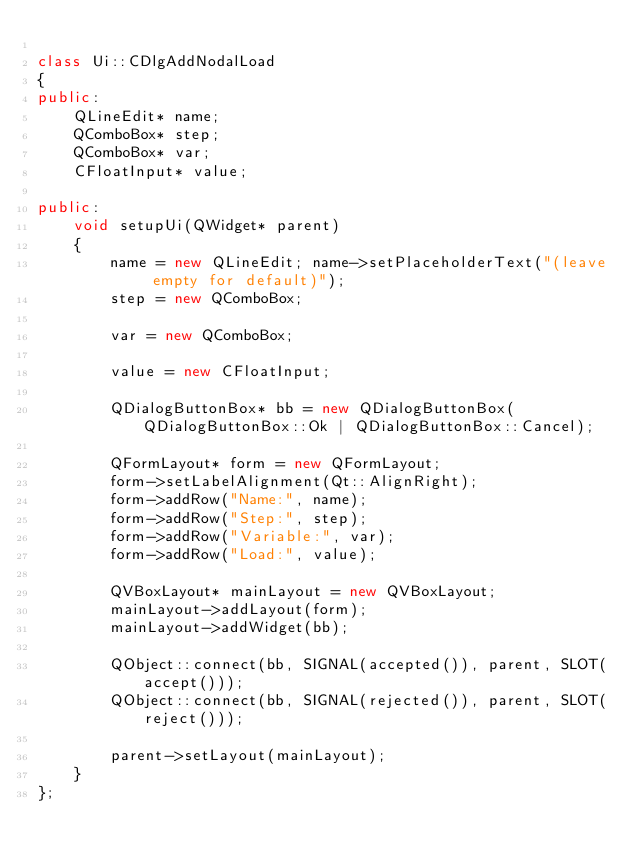<code> <loc_0><loc_0><loc_500><loc_500><_C++_>
class Ui::CDlgAddNodalLoad
{
public:
	QLineEdit* name;
	QComboBox* step;
	QComboBox* var;
	CFloatInput* value;

public:
	void setupUi(QWidget* parent)
	{
		name = new QLineEdit; name->setPlaceholderText("(leave empty for default)");
		step = new QComboBox;

		var = new QComboBox;

		value = new CFloatInput;

		QDialogButtonBox* bb = new QDialogButtonBox(QDialogButtonBox::Ok | QDialogButtonBox::Cancel);

		QFormLayout* form = new QFormLayout;
		form->setLabelAlignment(Qt::AlignRight);
		form->addRow("Name:", name);
		form->addRow("Step:", step);
		form->addRow("Variable:", var);
		form->addRow("Load:", value);

		QVBoxLayout* mainLayout = new QVBoxLayout;
		mainLayout->addLayout(form);
		mainLayout->addWidget(bb);

		QObject::connect(bb, SIGNAL(accepted()), parent, SLOT(accept()));
		QObject::connect(bb, SIGNAL(rejected()), parent, SLOT(reject()));

		parent->setLayout(mainLayout);
	}
};
</code> 